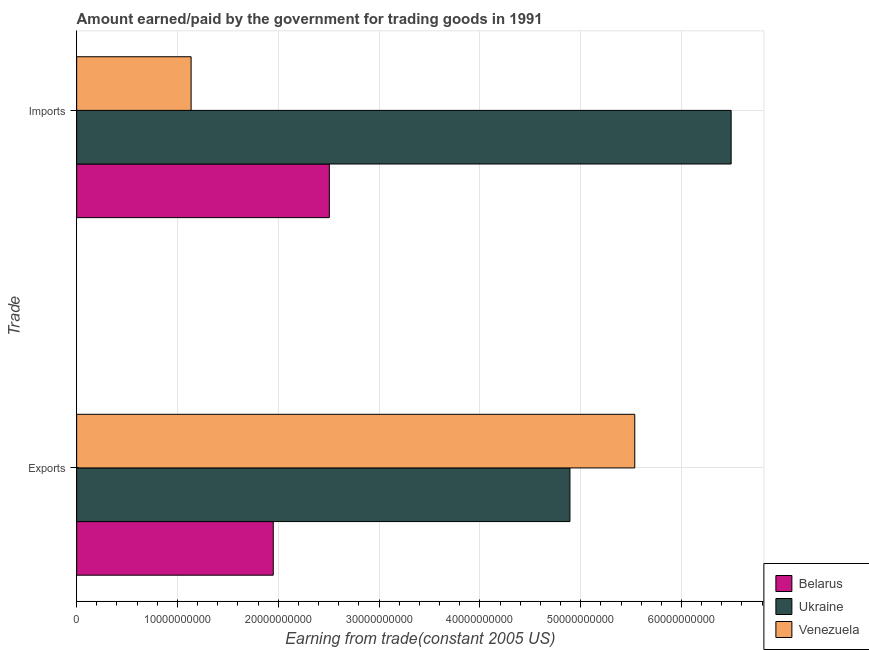How many groups of bars are there?
Offer a terse response. 2. Are the number of bars per tick equal to the number of legend labels?
Your response must be concise. Yes. How many bars are there on the 1st tick from the top?
Keep it short and to the point. 3. What is the label of the 1st group of bars from the top?
Give a very brief answer. Imports. What is the amount paid for imports in Belarus?
Keep it short and to the point. 2.51e+1. Across all countries, what is the maximum amount earned from exports?
Your response must be concise. 5.54e+1. Across all countries, what is the minimum amount paid for imports?
Your response must be concise. 1.14e+1. In which country was the amount paid for imports maximum?
Your response must be concise. Ukraine. In which country was the amount paid for imports minimum?
Make the answer very short. Venezuela. What is the total amount paid for imports in the graph?
Offer a terse response. 1.01e+11. What is the difference between the amount paid for imports in Belarus and that in Ukraine?
Keep it short and to the point. -3.99e+1. What is the difference between the amount earned from exports in Belarus and the amount paid for imports in Venezuela?
Make the answer very short. 8.15e+09. What is the average amount earned from exports per country?
Your answer should be very brief. 4.13e+1. What is the difference between the amount paid for imports and amount earned from exports in Ukraine?
Make the answer very short. 1.60e+1. In how many countries, is the amount paid for imports greater than 34000000000 US$?
Your answer should be very brief. 1. What is the ratio of the amount earned from exports in Belarus to that in Venezuela?
Your response must be concise. 0.35. Is the amount earned from exports in Belarus less than that in Ukraine?
Your answer should be compact. Yes. What does the 3rd bar from the top in Imports represents?
Give a very brief answer. Belarus. What does the 1st bar from the bottom in Imports represents?
Provide a succinct answer. Belarus. How many bars are there?
Keep it short and to the point. 6. Are all the bars in the graph horizontal?
Your answer should be very brief. Yes. How many countries are there in the graph?
Ensure brevity in your answer.  3. Does the graph contain any zero values?
Offer a terse response. No. How are the legend labels stacked?
Offer a terse response. Vertical. What is the title of the graph?
Offer a terse response. Amount earned/paid by the government for trading goods in 1991. Does "United States" appear as one of the legend labels in the graph?
Offer a very short reply. No. What is the label or title of the X-axis?
Your answer should be compact. Earning from trade(constant 2005 US). What is the label or title of the Y-axis?
Give a very brief answer. Trade. What is the Earning from trade(constant 2005 US) of Belarus in Exports?
Your answer should be compact. 1.95e+1. What is the Earning from trade(constant 2005 US) of Ukraine in Exports?
Offer a terse response. 4.89e+1. What is the Earning from trade(constant 2005 US) in Venezuela in Exports?
Offer a very short reply. 5.54e+1. What is the Earning from trade(constant 2005 US) in Belarus in Imports?
Your response must be concise. 2.51e+1. What is the Earning from trade(constant 2005 US) in Ukraine in Imports?
Ensure brevity in your answer.  6.49e+1. What is the Earning from trade(constant 2005 US) of Venezuela in Imports?
Provide a succinct answer. 1.14e+1. Across all Trade, what is the maximum Earning from trade(constant 2005 US) of Belarus?
Your answer should be compact. 2.51e+1. Across all Trade, what is the maximum Earning from trade(constant 2005 US) in Ukraine?
Give a very brief answer. 6.49e+1. Across all Trade, what is the maximum Earning from trade(constant 2005 US) of Venezuela?
Provide a short and direct response. 5.54e+1. Across all Trade, what is the minimum Earning from trade(constant 2005 US) in Belarus?
Offer a very short reply. 1.95e+1. Across all Trade, what is the minimum Earning from trade(constant 2005 US) in Ukraine?
Offer a terse response. 4.89e+1. Across all Trade, what is the minimum Earning from trade(constant 2005 US) of Venezuela?
Provide a succinct answer. 1.14e+1. What is the total Earning from trade(constant 2005 US) of Belarus in the graph?
Keep it short and to the point. 4.46e+1. What is the total Earning from trade(constant 2005 US) in Ukraine in the graph?
Make the answer very short. 1.14e+11. What is the total Earning from trade(constant 2005 US) of Venezuela in the graph?
Make the answer very short. 6.67e+1. What is the difference between the Earning from trade(constant 2005 US) of Belarus in Exports and that in Imports?
Keep it short and to the point. -5.56e+09. What is the difference between the Earning from trade(constant 2005 US) of Ukraine in Exports and that in Imports?
Make the answer very short. -1.60e+1. What is the difference between the Earning from trade(constant 2005 US) in Venezuela in Exports and that in Imports?
Your answer should be compact. 4.40e+1. What is the difference between the Earning from trade(constant 2005 US) in Belarus in Exports and the Earning from trade(constant 2005 US) in Ukraine in Imports?
Offer a terse response. -4.54e+1. What is the difference between the Earning from trade(constant 2005 US) in Belarus in Exports and the Earning from trade(constant 2005 US) in Venezuela in Imports?
Your answer should be very brief. 8.15e+09. What is the difference between the Earning from trade(constant 2005 US) in Ukraine in Exports and the Earning from trade(constant 2005 US) in Venezuela in Imports?
Keep it short and to the point. 3.76e+1. What is the average Earning from trade(constant 2005 US) of Belarus per Trade?
Your answer should be compact. 2.23e+1. What is the average Earning from trade(constant 2005 US) of Ukraine per Trade?
Keep it short and to the point. 5.69e+1. What is the average Earning from trade(constant 2005 US) in Venezuela per Trade?
Provide a short and direct response. 3.34e+1. What is the difference between the Earning from trade(constant 2005 US) in Belarus and Earning from trade(constant 2005 US) in Ukraine in Exports?
Make the answer very short. -2.94e+1. What is the difference between the Earning from trade(constant 2005 US) in Belarus and Earning from trade(constant 2005 US) in Venezuela in Exports?
Make the answer very short. -3.59e+1. What is the difference between the Earning from trade(constant 2005 US) in Ukraine and Earning from trade(constant 2005 US) in Venezuela in Exports?
Ensure brevity in your answer.  -6.43e+09. What is the difference between the Earning from trade(constant 2005 US) in Belarus and Earning from trade(constant 2005 US) in Ukraine in Imports?
Provide a short and direct response. -3.99e+1. What is the difference between the Earning from trade(constant 2005 US) in Belarus and Earning from trade(constant 2005 US) in Venezuela in Imports?
Keep it short and to the point. 1.37e+1. What is the difference between the Earning from trade(constant 2005 US) in Ukraine and Earning from trade(constant 2005 US) in Venezuela in Imports?
Your response must be concise. 5.36e+1. What is the ratio of the Earning from trade(constant 2005 US) in Belarus in Exports to that in Imports?
Ensure brevity in your answer.  0.78. What is the ratio of the Earning from trade(constant 2005 US) in Ukraine in Exports to that in Imports?
Your answer should be very brief. 0.75. What is the ratio of the Earning from trade(constant 2005 US) of Venezuela in Exports to that in Imports?
Provide a short and direct response. 4.88. What is the difference between the highest and the second highest Earning from trade(constant 2005 US) in Belarus?
Ensure brevity in your answer.  5.56e+09. What is the difference between the highest and the second highest Earning from trade(constant 2005 US) of Ukraine?
Offer a terse response. 1.60e+1. What is the difference between the highest and the second highest Earning from trade(constant 2005 US) in Venezuela?
Your answer should be compact. 4.40e+1. What is the difference between the highest and the lowest Earning from trade(constant 2005 US) in Belarus?
Provide a short and direct response. 5.56e+09. What is the difference between the highest and the lowest Earning from trade(constant 2005 US) of Ukraine?
Your response must be concise. 1.60e+1. What is the difference between the highest and the lowest Earning from trade(constant 2005 US) of Venezuela?
Your answer should be very brief. 4.40e+1. 